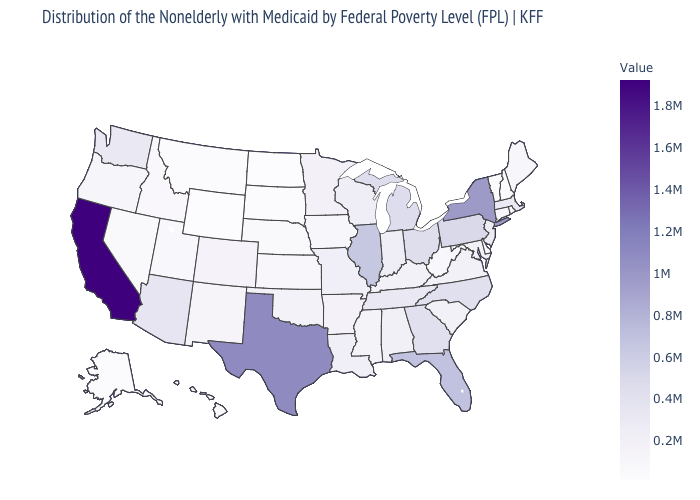Does California have the highest value in the USA?
Give a very brief answer. Yes. Which states hav the highest value in the MidWest?
Give a very brief answer. Illinois. Does California have a lower value than Alaska?
Answer briefly. No. Which states have the highest value in the USA?
Short answer required. California. 